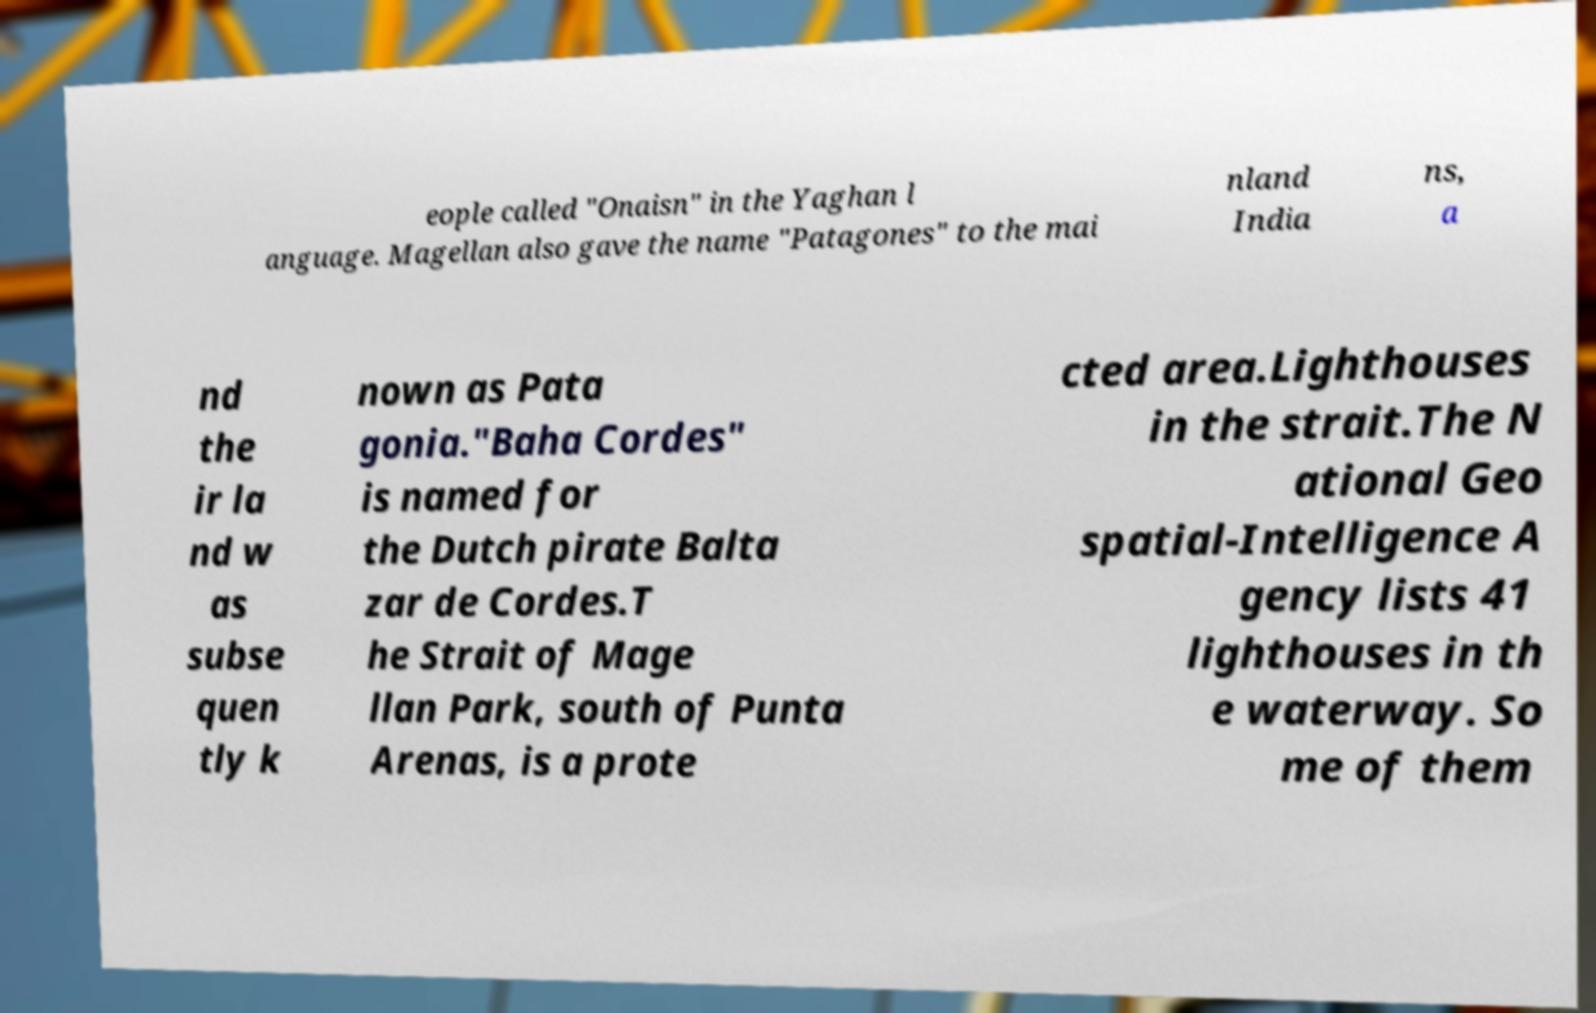Please identify and transcribe the text found in this image. eople called "Onaisn" in the Yaghan l anguage. Magellan also gave the name "Patagones" to the mai nland India ns, a nd the ir la nd w as subse quen tly k nown as Pata gonia."Baha Cordes" is named for the Dutch pirate Balta zar de Cordes.T he Strait of Mage llan Park, south of Punta Arenas, is a prote cted area.Lighthouses in the strait.The N ational Geo spatial-Intelligence A gency lists 41 lighthouses in th e waterway. So me of them 